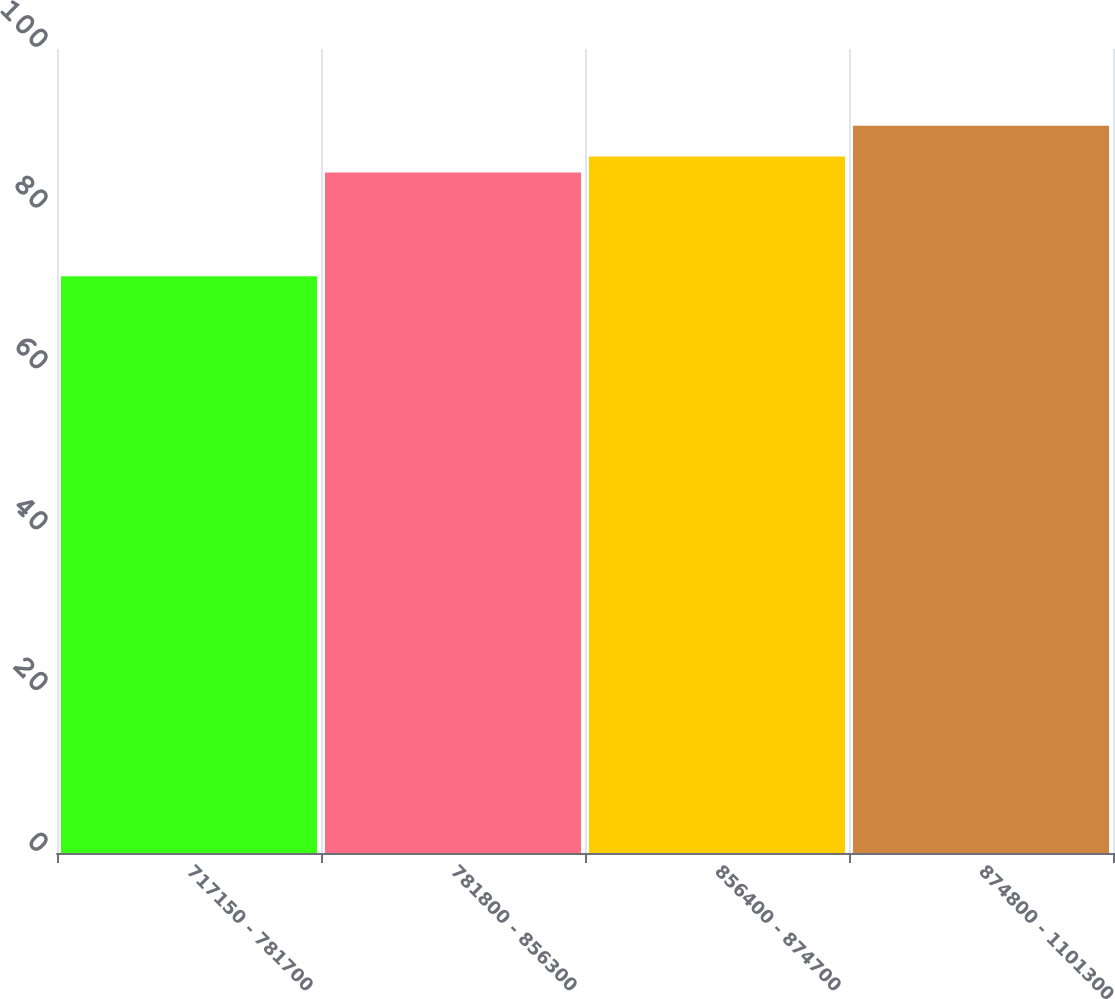<chart> <loc_0><loc_0><loc_500><loc_500><bar_chart><fcel>717150 - 781700<fcel>781800 - 856300<fcel>856400 - 874700<fcel>874800 - 1101300<nl><fcel>71.72<fcel>84.63<fcel>86.62<fcel>90.46<nl></chart> 